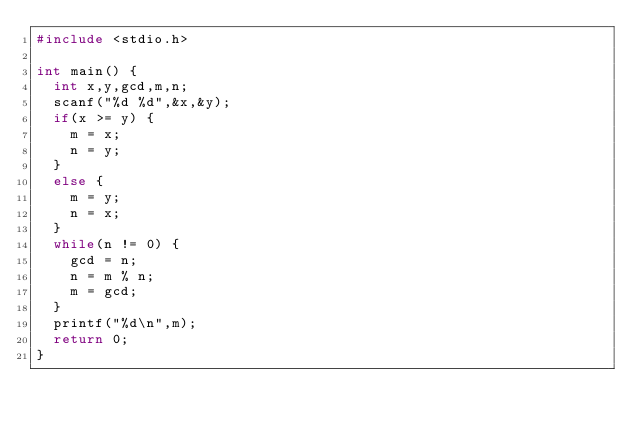<code> <loc_0><loc_0><loc_500><loc_500><_C_>#include <stdio.h>

int main() {
  int x,y,gcd,m,n;
  scanf("%d %d",&x,&y);
  if(x >= y) {
    m = x;
    n = y;
  }
  else {
    m = y;
    n = x;
  }
  while(n != 0) {
    gcd = n;
    n = m % n;
    m = gcd;
  }
  printf("%d\n",m);
  return 0;
}</code> 